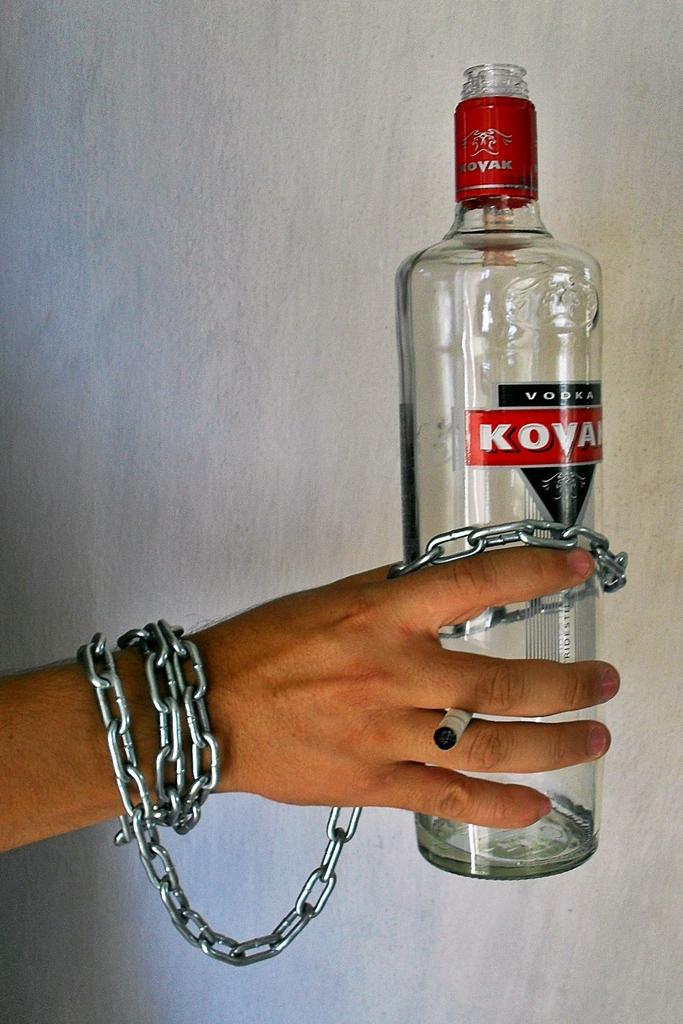What is the name of the brand on the bottle?
Make the answer very short. Kovak. 